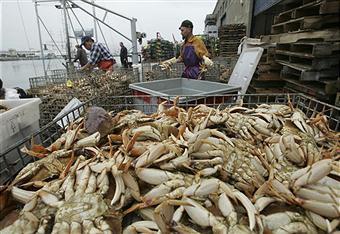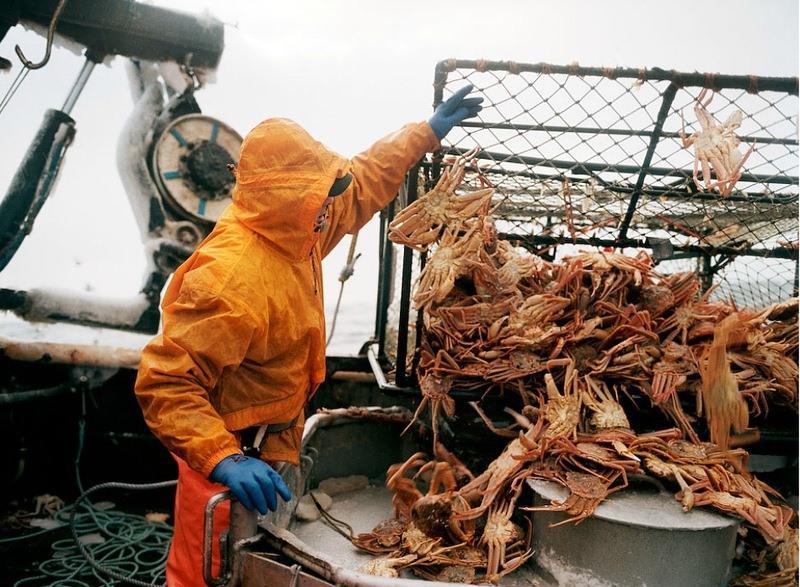The first image is the image on the left, the second image is the image on the right. Examine the images to the left and right. Is the description "Crabs are being dumped out of a container." accurate? Answer yes or no. Yes. The first image is the image on the left, the second image is the image on the right. For the images shown, is this caption "In at least one image, the crabs have a blue tint near the claws." true? Answer yes or no. No. 